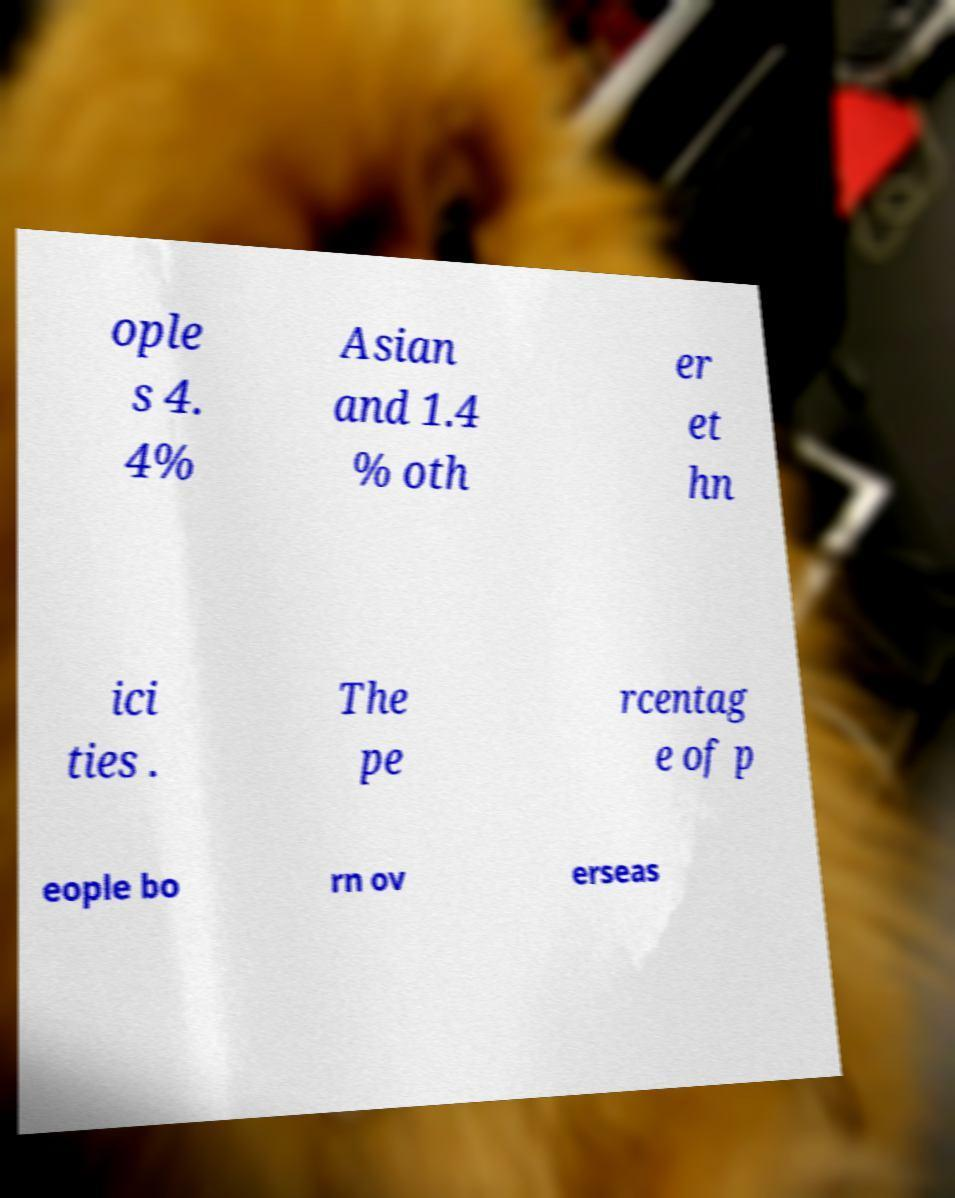What messages or text are displayed in this image? I need them in a readable, typed format. ople s 4. 4% Asian and 1.4 % oth er et hn ici ties . The pe rcentag e of p eople bo rn ov erseas 